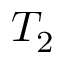Convert formula to latex. <formula><loc_0><loc_0><loc_500><loc_500>T _ { 2 }</formula> 